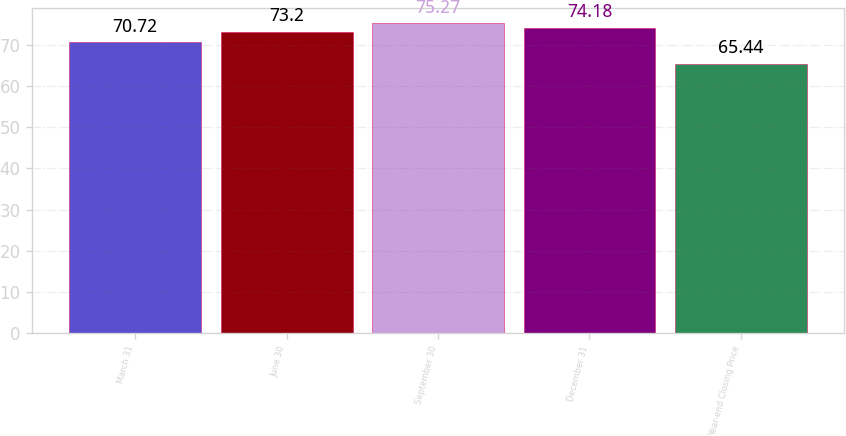Convert chart to OTSL. <chart><loc_0><loc_0><loc_500><loc_500><bar_chart><fcel>March 31<fcel>June 30<fcel>September 30<fcel>December 31<fcel>Year-end Closing Price<nl><fcel>70.72<fcel>73.2<fcel>75.27<fcel>74.18<fcel>65.44<nl></chart> 